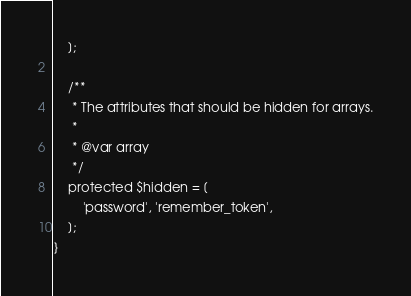Convert code to text. <code><loc_0><loc_0><loc_500><loc_500><_PHP_>    ];

    /**
     * The attributes that should be hidden for arrays.
     *
     * @var array
     */
    protected $hidden = [
        'password', 'remember_token',
    ];
}
</code> 